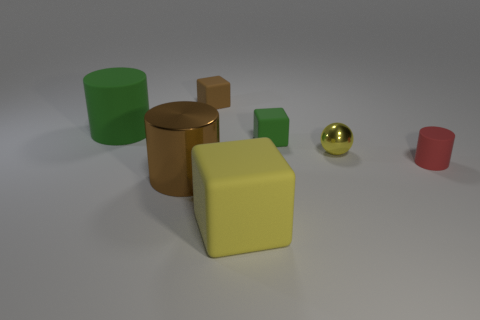Subtract all large brown cylinders. How many cylinders are left? 2 Add 2 rubber cylinders. How many objects exist? 9 Subtract all brown blocks. How many blocks are left? 2 Subtract all cylinders. How many objects are left? 4 Subtract 2 cylinders. How many cylinders are left? 1 Subtract all cyan balls. Subtract all blue cubes. How many balls are left? 1 Subtract all tiny red rubber things. Subtract all yellow spheres. How many objects are left? 5 Add 6 small red objects. How many small red objects are left? 7 Add 4 small red metallic blocks. How many small red metallic blocks exist? 4 Subtract 0 blue balls. How many objects are left? 7 